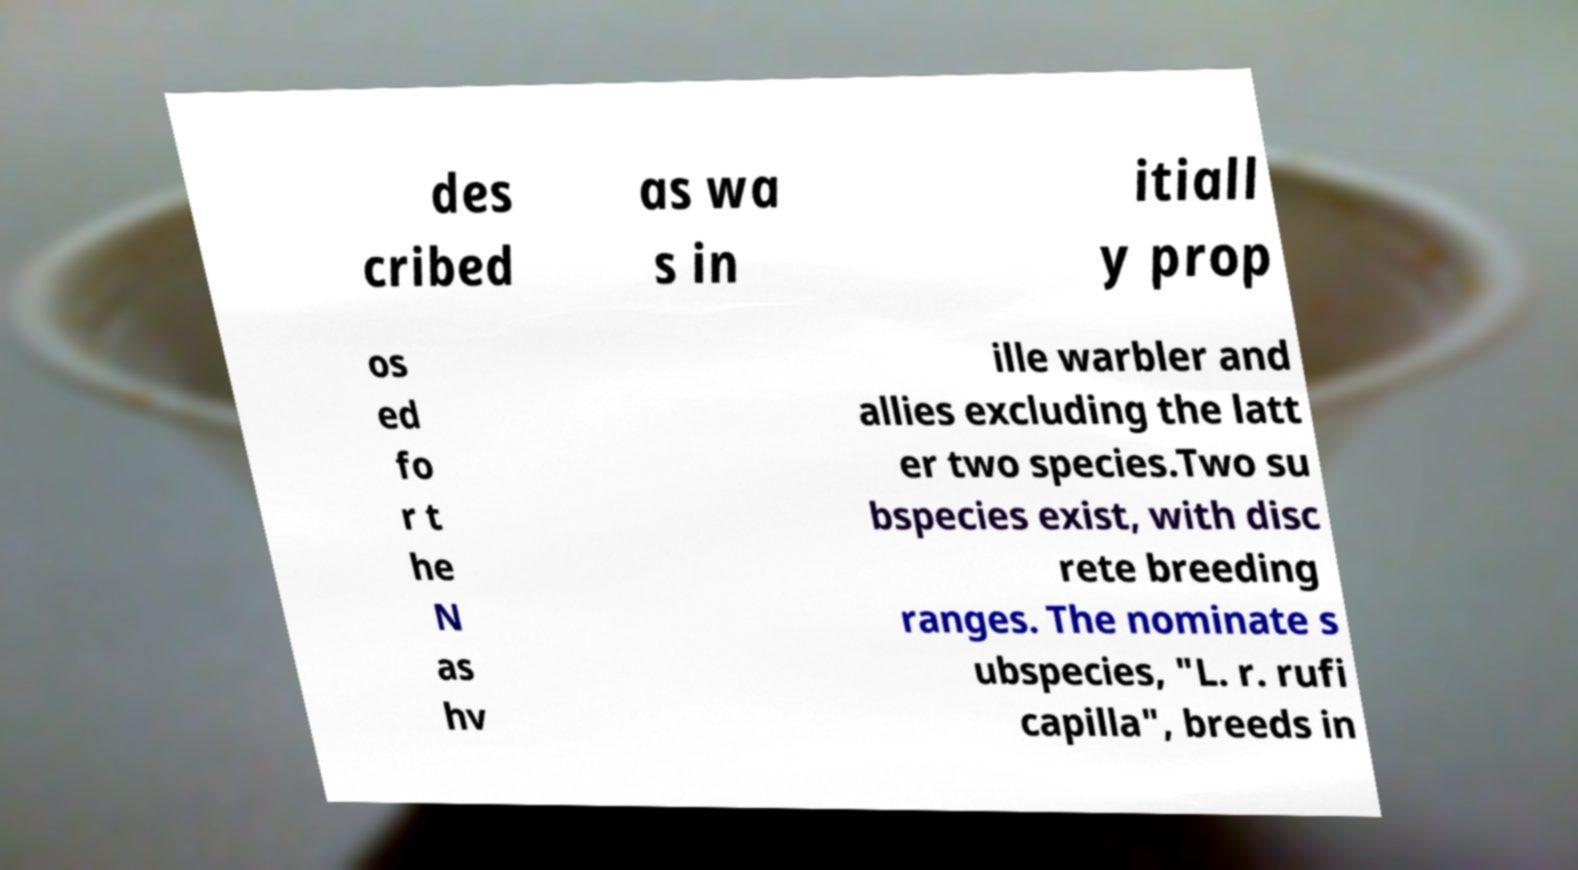For documentation purposes, I need the text within this image transcribed. Could you provide that? des cribed as wa s in itiall y prop os ed fo r t he N as hv ille warbler and allies excluding the latt er two species.Two su bspecies exist, with disc rete breeding ranges. The nominate s ubspecies, "L. r. rufi capilla", breeds in 